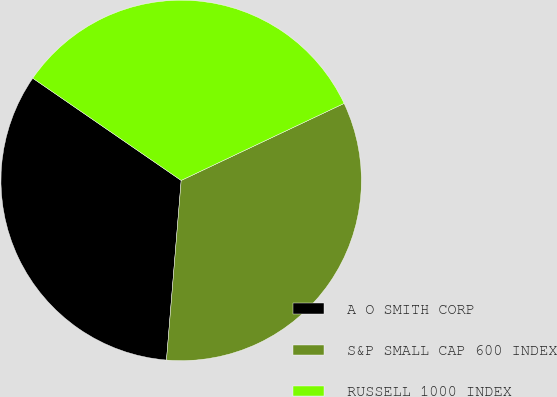<chart> <loc_0><loc_0><loc_500><loc_500><pie_chart><fcel>A O SMITH CORP<fcel>S&P SMALL CAP 600 INDEX<fcel>RUSSELL 1000 INDEX<nl><fcel>33.3%<fcel>33.33%<fcel>33.37%<nl></chart> 